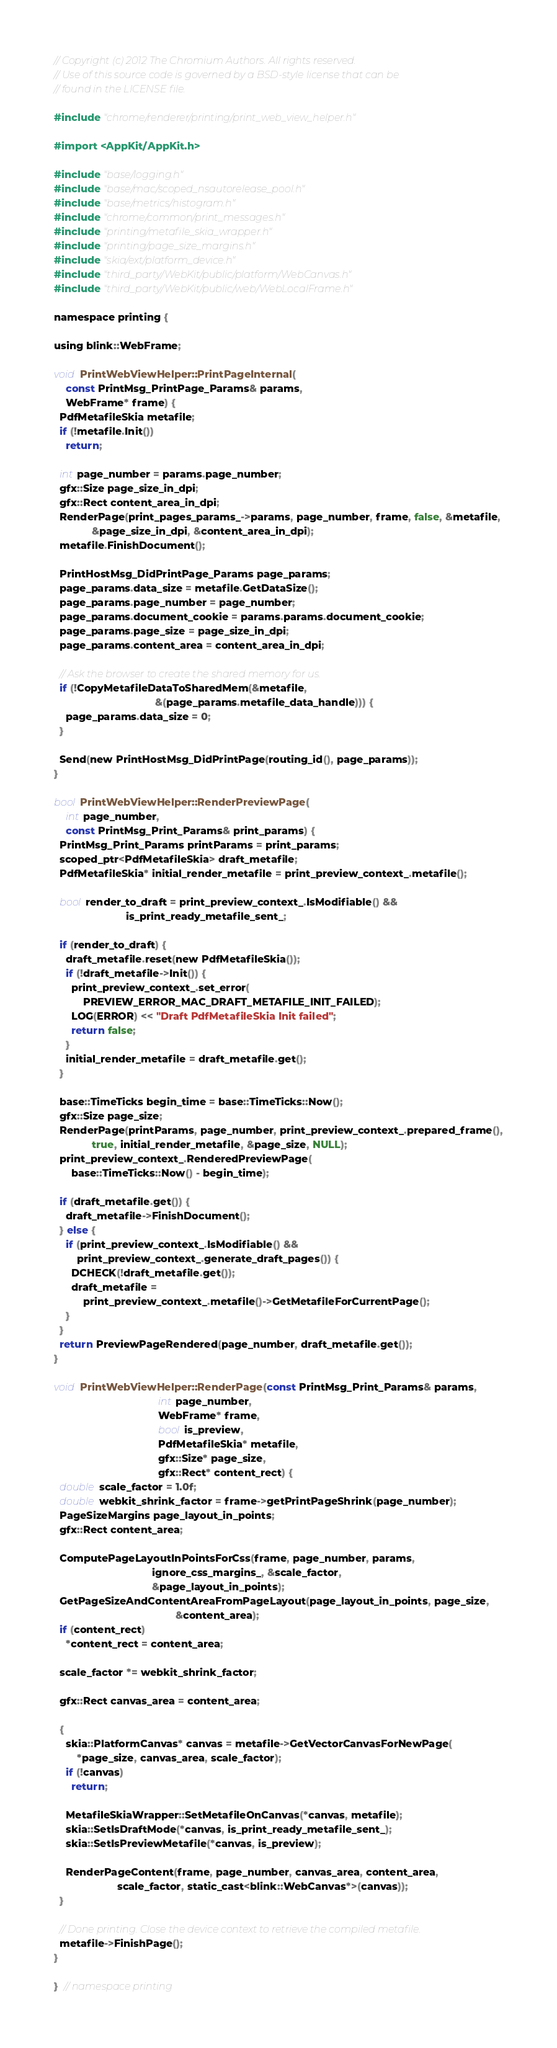Convert code to text. <code><loc_0><loc_0><loc_500><loc_500><_ObjectiveC_>// Copyright (c) 2012 The Chromium Authors. All rights reserved.
// Use of this source code is governed by a BSD-style license that can be
// found in the LICENSE file.

#include "chrome/renderer/printing/print_web_view_helper.h"

#import <AppKit/AppKit.h>

#include "base/logging.h"
#include "base/mac/scoped_nsautorelease_pool.h"
#include "base/metrics/histogram.h"
#include "chrome/common/print_messages.h"
#include "printing/metafile_skia_wrapper.h"
#include "printing/page_size_margins.h"
#include "skia/ext/platform_device.h"
#include "third_party/WebKit/public/platform/WebCanvas.h"
#include "third_party/WebKit/public/web/WebLocalFrame.h"

namespace printing {

using blink::WebFrame;

void PrintWebViewHelper::PrintPageInternal(
    const PrintMsg_PrintPage_Params& params,
    WebFrame* frame) {
  PdfMetafileSkia metafile;
  if (!metafile.Init())
    return;

  int page_number = params.page_number;
  gfx::Size page_size_in_dpi;
  gfx::Rect content_area_in_dpi;
  RenderPage(print_pages_params_->params, page_number, frame, false, &metafile,
             &page_size_in_dpi, &content_area_in_dpi);
  metafile.FinishDocument();

  PrintHostMsg_DidPrintPage_Params page_params;
  page_params.data_size = metafile.GetDataSize();
  page_params.page_number = page_number;
  page_params.document_cookie = params.params.document_cookie;
  page_params.page_size = page_size_in_dpi;
  page_params.content_area = content_area_in_dpi;

  // Ask the browser to create the shared memory for us.
  if (!CopyMetafileDataToSharedMem(&metafile,
                                   &(page_params.metafile_data_handle))) {
    page_params.data_size = 0;
  }

  Send(new PrintHostMsg_DidPrintPage(routing_id(), page_params));
}

bool PrintWebViewHelper::RenderPreviewPage(
    int page_number,
    const PrintMsg_Print_Params& print_params) {
  PrintMsg_Print_Params printParams = print_params;
  scoped_ptr<PdfMetafileSkia> draft_metafile;
  PdfMetafileSkia* initial_render_metafile = print_preview_context_.metafile();

  bool render_to_draft = print_preview_context_.IsModifiable() &&
                         is_print_ready_metafile_sent_;

  if (render_to_draft) {
    draft_metafile.reset(new PdfMetafileSkia());
    if (!draft_metafile->Init()) {
      print_preview_context_.set_error(
          PREVIEW_ERROR_MAC_DRAFT_METAFILE_INIT_FAILED);
      LOG(ERROR) << "Draft PdfMetafileSkia Init failed";
      return false;
    }
    initial_render_metafile = draft_metafile.get();
  }

  base::TimeTicks begin_time = base::TimeTicks::Now();
  gfx::Size page_size;
  RenderPage(printParams, page_number, print_preview_context_.prepared_frame(),
             true, initial_render_metafile, &page_size, NULL);
  print_preview_context_.RenderedPreviewPage(
      base::TimeTicks::Now() - begin_time);

  if (draft_metafile.get()) {
    draft_metafile->FinishDocument();
  } else {
    if (print_preview_context_.IsModifiable() &&
        print_preview_context_.generate_draft_pages()) {
      DCHECK(!draft_metafile.get());
      draft_metafile =
          print_preview_context_.metafile()->GetMetafileForCurrentPage();
    }
  }
  return PreviewPageRendered(page_number, draft_metafile.get());
}

void PrintWebViewHelper::RenderPage(const PrintMsg_Print_Params& params,
                                    int page_number,
                                    WebFrame* frame,
                                    bool is_preview,
                                    PdfMetafileSkia* metafile,
                                    gfx::Size* page_size,
                                    gfx::Rect* content_rect) {
  double scale_factor = 1.0f;
  double webkit_shrink_factor = frame->getPrintPageShrink(page_number);
  PageSizeMargins page_layout_in_points;
  gfx::Rect content_area;

  ComputePageLayoutInPointsForCss(frame, page_number, params,
                                  ignore_css_margins_, &scale_factor,
                                  &page_layout_in_points);
  GetPageSizeAndContentAreaFromPageLayout(page_layout_in_points, page_size,
                                          &content_area);
  if (content_rect)
    *content_rect = content_area;

  scale_factor *= webkit_shrink_factor;

  gfx::Rect canvas_area = content_area;

  {
    skia::PlatformCanvas* canvas = metafile->GetVectorCanvasForNewPage(
        *page_size, canvas_area, scale_factor);
    if (!canvas)
      return;

    MetafileSkiaWrapper::SetMetafileOnCanvas(*canvas, metafile);
    skia::SetIsDraftMode(*canvas, is_print_ready_metafile_sent_);
    skia::SetIsPreviewMetafile(*canvas, is_preview);

    RenderPageContent(frame, page_number, canvas_area, content_area,
                      scale_factor, static_cast<blink::WebCanvas*>(canvas));
  }

  // Done printing. Close the device context to retrieve the compiled metafile.
  metafile->FinishPage();
}

}  // namespace printing
</code> 